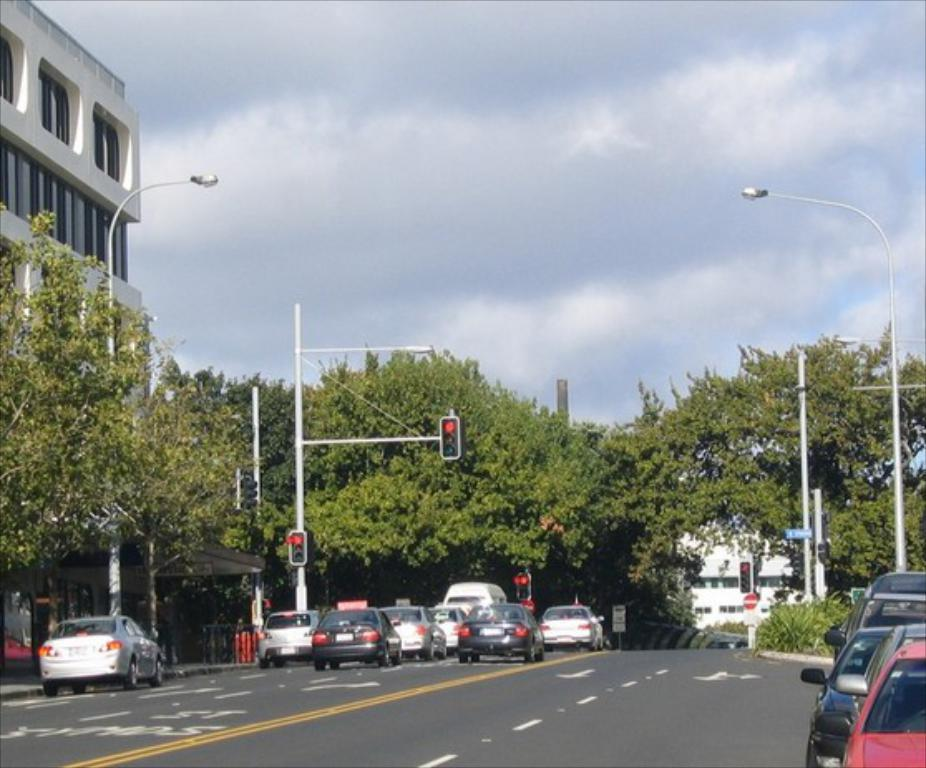What type of vehicles can be seen on the road in the image? There are motor vehicles on the road in the image. What structures are present along the road? Traffic poles, traffic signals, street poles, and street lights are visible in the image. What other objects can be seen in the image? Sign boards, trees, buildings, and the sky are present in the image. What is the condition of the sky in the image? The sky is visible in the image, and clouds are present. Can you tell me how many actors are performing on the ship in the image? There is no ship or actors present in the image. What type of cracker is being used to decorate the sign boards in the image? There are no crackers present in the image, and sign boards are not being decorated. 